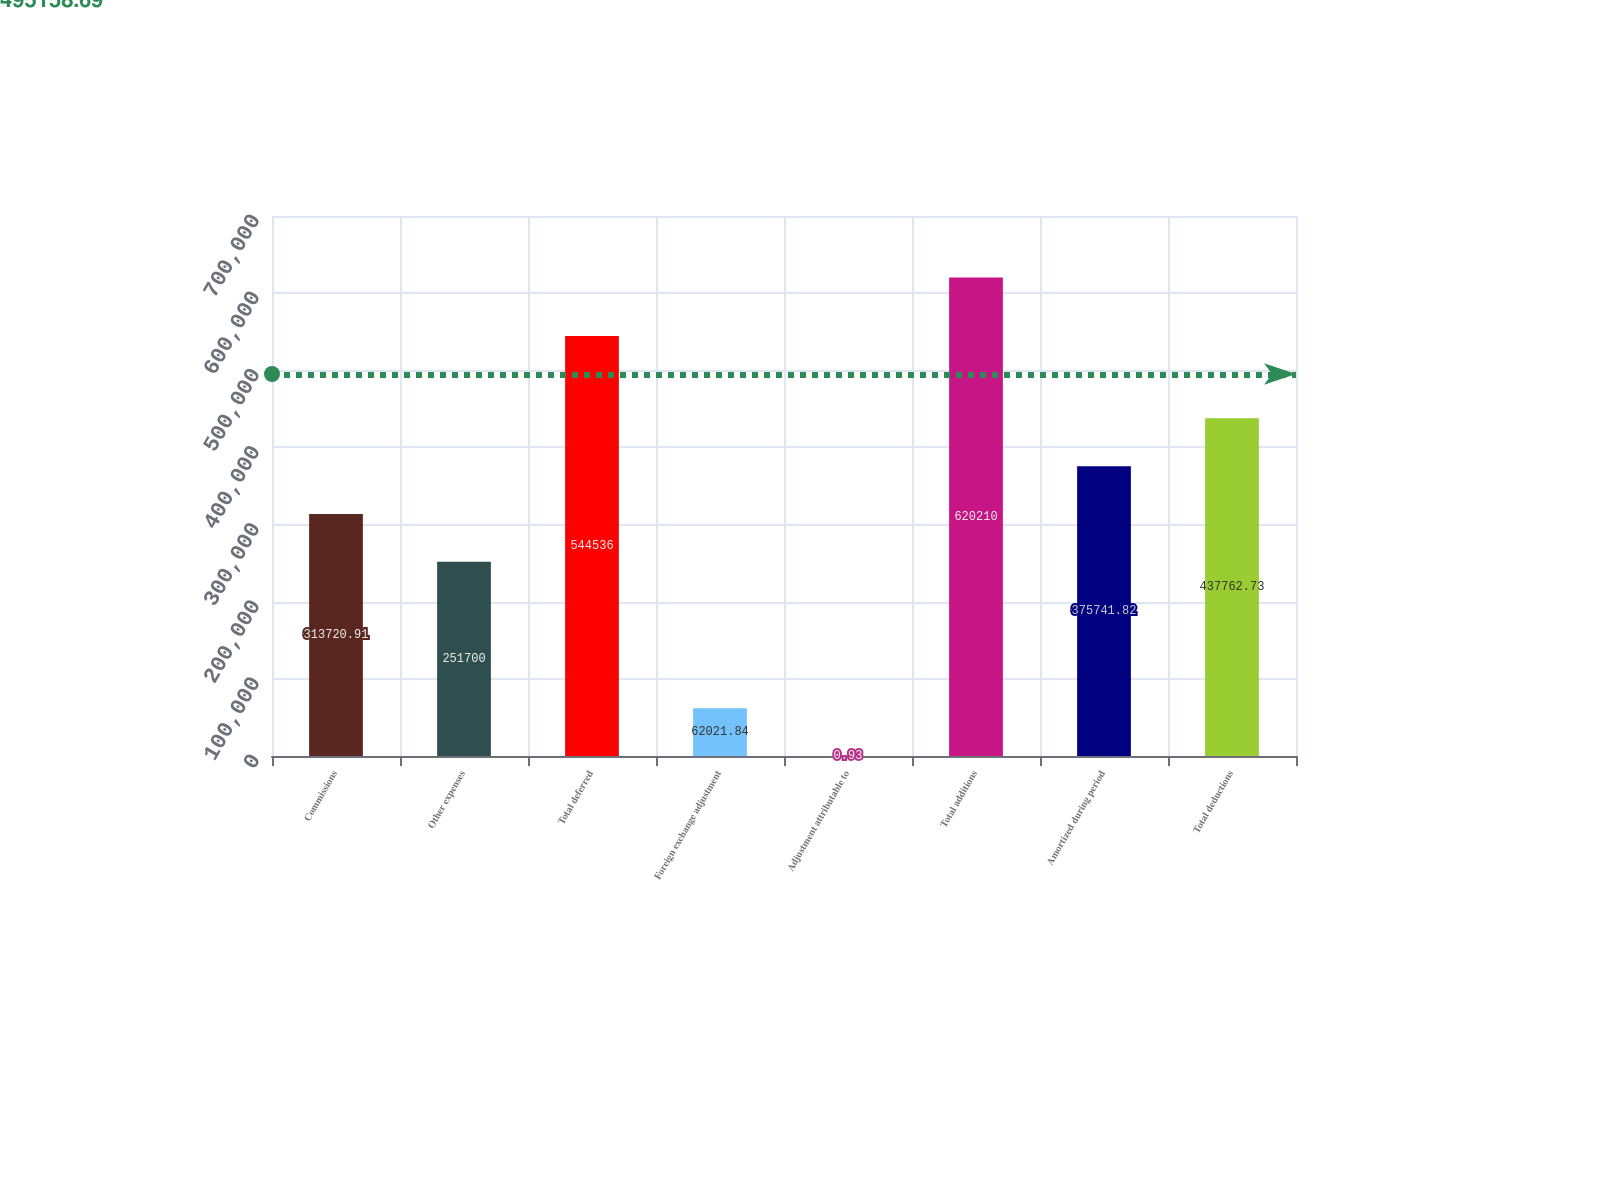<chart> <loc_0><loc_0><loc_500><loc_500><bar_chart><fcel>Commissions<fcel>Other expenses<fcel>Total deferred<fcel>Foreign exchange adjustment<fcel>Adjustment attributable to<fcel>Total additions<fcel>Amortized during period<fcel>Total deductions<nl><fcel>313721<fcel>251700<fcel>544536<fcel>62021.8<fcel>0.93<fcel>620210<fcel>375742<fcel>437763<nl></chart> 